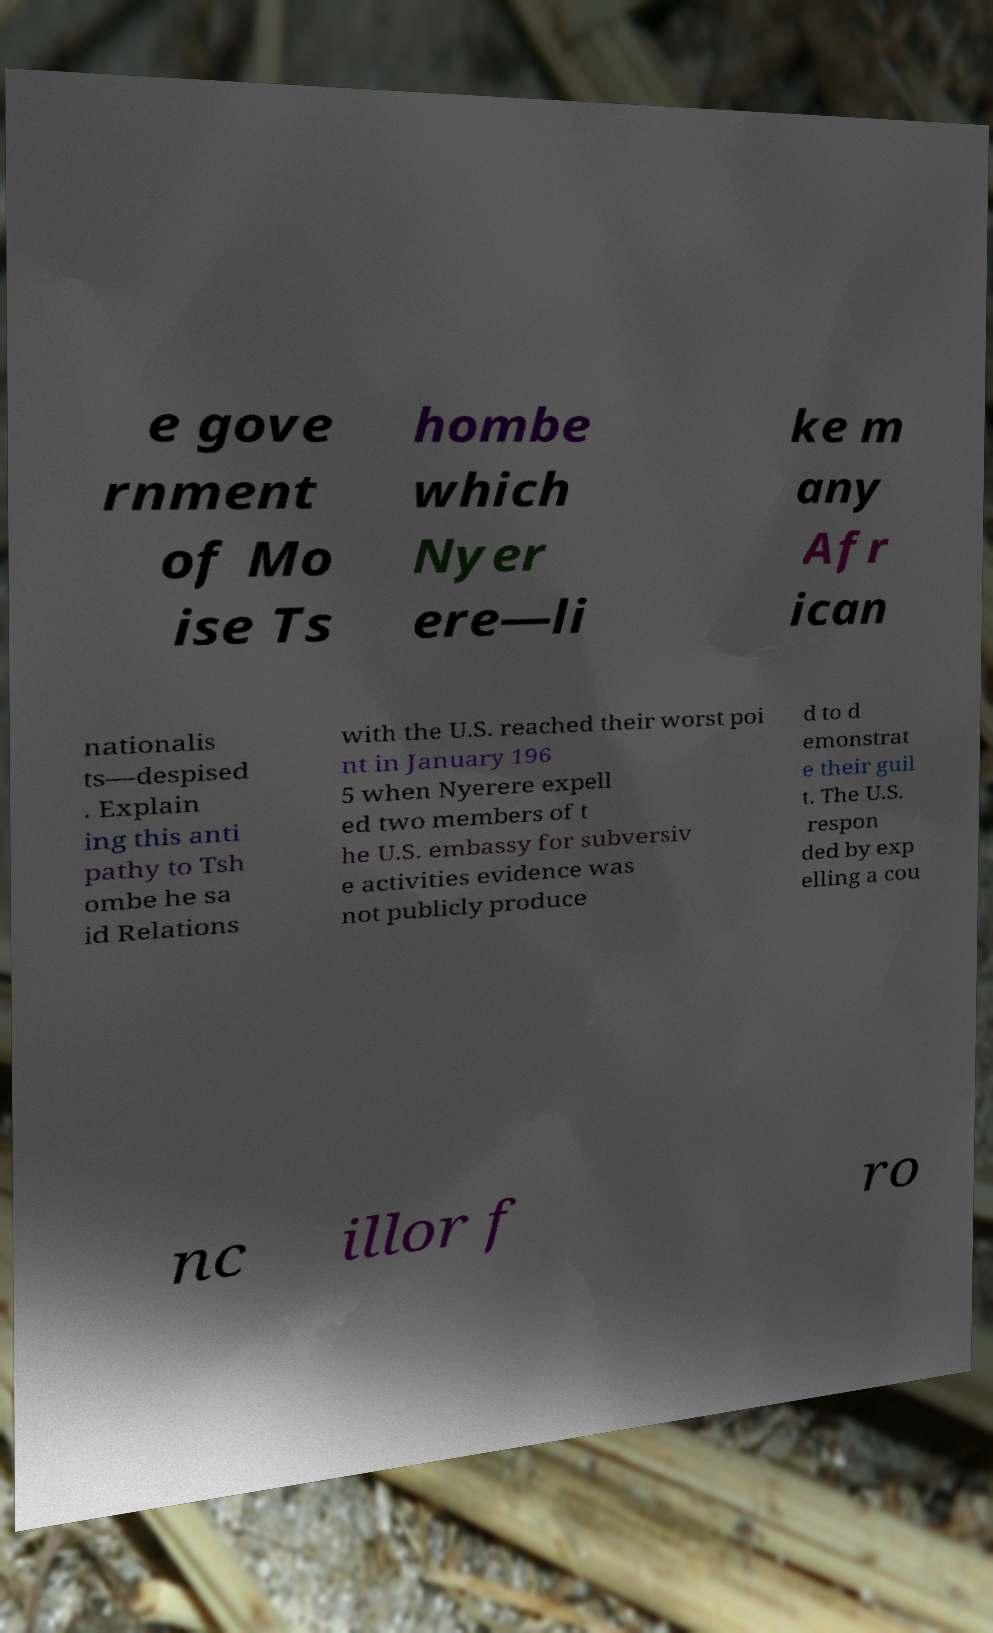There's text embedded in this image that I need extracted. Can you transcribe it verbatim? e gove rnment of Mo ise Ts hombe which Nyer ere—li ke m any Afr ican nationalis ts—despised . Explain ing this anti pathy to Tsh ombe he sa id Relations with the U.S. reached their worst poi nt in January 196 5 when Nyerere expell ed two members of t he U.S. embassy for subversiv e activities evidence was not publicly produce d to d emonstrat e their guil t. The U.S. respon ded by exp elling a cou nc illor f ro 